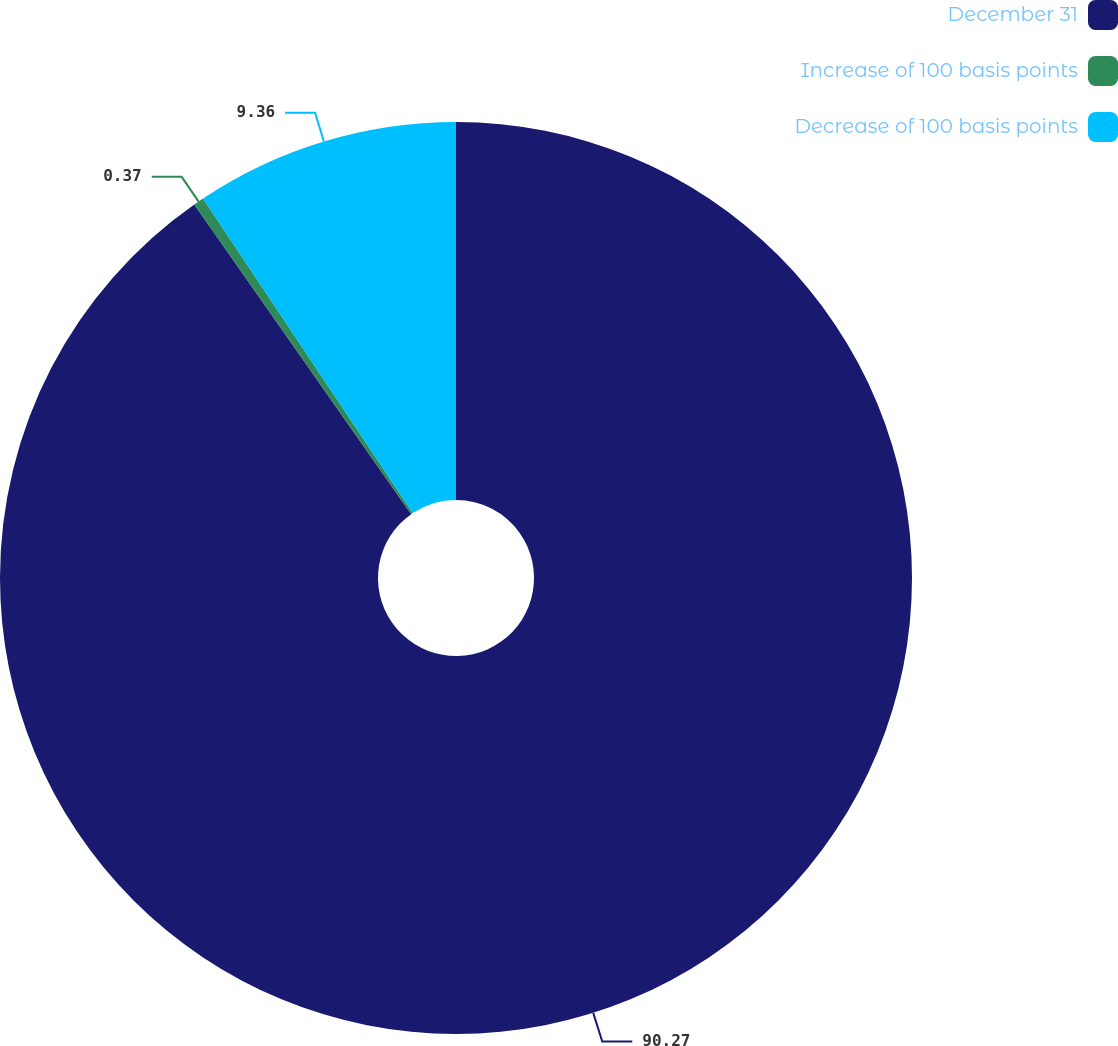Convert chart to OTSL. <chart><loc_0><loc_0><loc_500><loc_500><pie_chart><fcel>December 31<fcel>Increase of 100 basis points<fcel>Decrease of 100 basis points<nl><fcel>90.27%<fcel>0.37%<fcel>9.36%<nl></chart> 